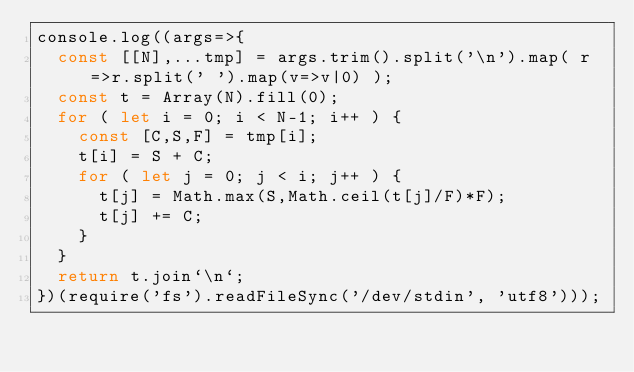<code> <loc_0><loc_0><loc_500><loc_500><_JavaScript_>console.log((args=>{
  const [[N],...tmp] = args.trim().split('\n').map( r=>r.split(' ').map(v=>v|0) );
  const t = Array(N).fill(0);
  for ( let i = 0; i < N-1; i++ ) {
    const [C,S,F] = tmp[i];
    t[i] = S + C; 
    for ( let j = 0; j < i; j++ ) {
      t[j] = Math.max(S,Math.ceil(t[j]/F)*F);
      t[j] += C;
    }
  }
  return t.join`\n`;
})(require('fs').readFileSync('/dev/stdin', 'utf8')));
</code> 